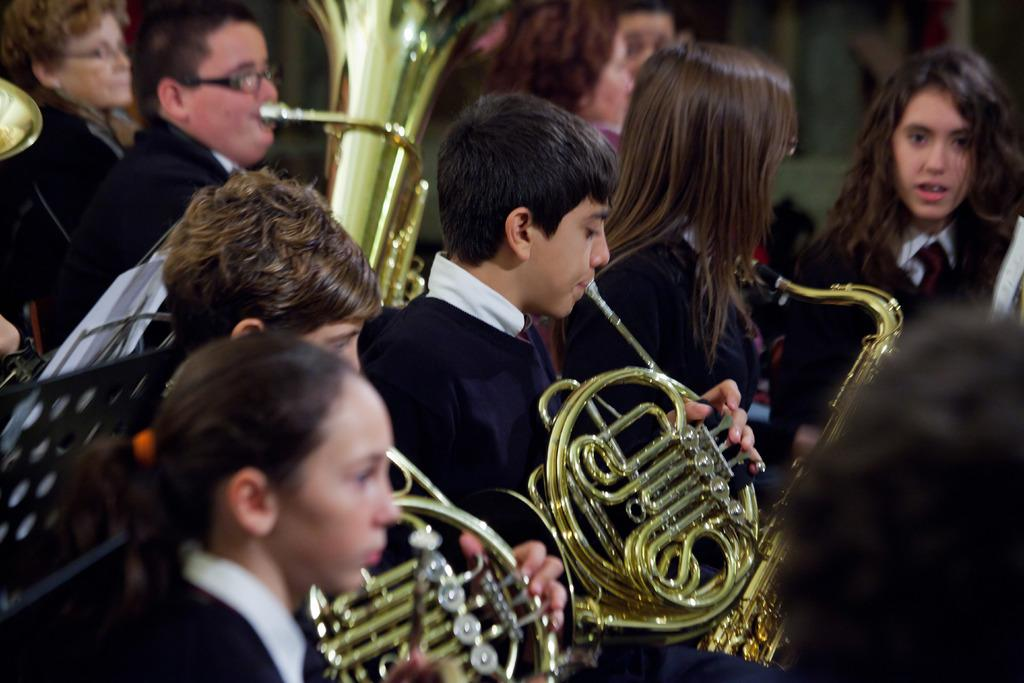What are the people in the image doing? The people in the image are playing musical instruments. Where are the people located in the image? The people are on the floor. What is the possible location where the image was taken? The image may have been taken in a hall. What type of clam can be seen playing a guitar in the image? There is no clam present in the image, and therefore no such activity can be observed. How many oranges are visible in the image? There are no oranges present in the image. 